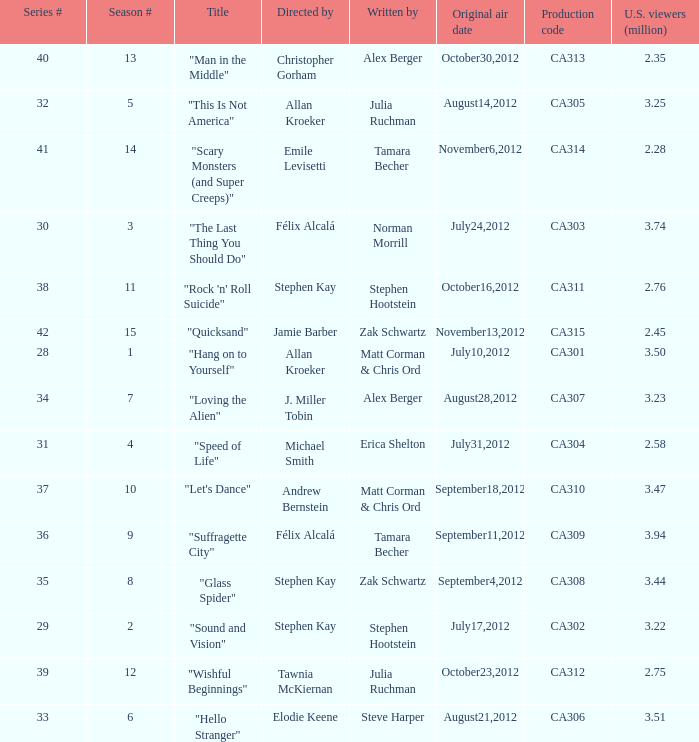Who directed the episode with production code ca311? Stephen Kay. 